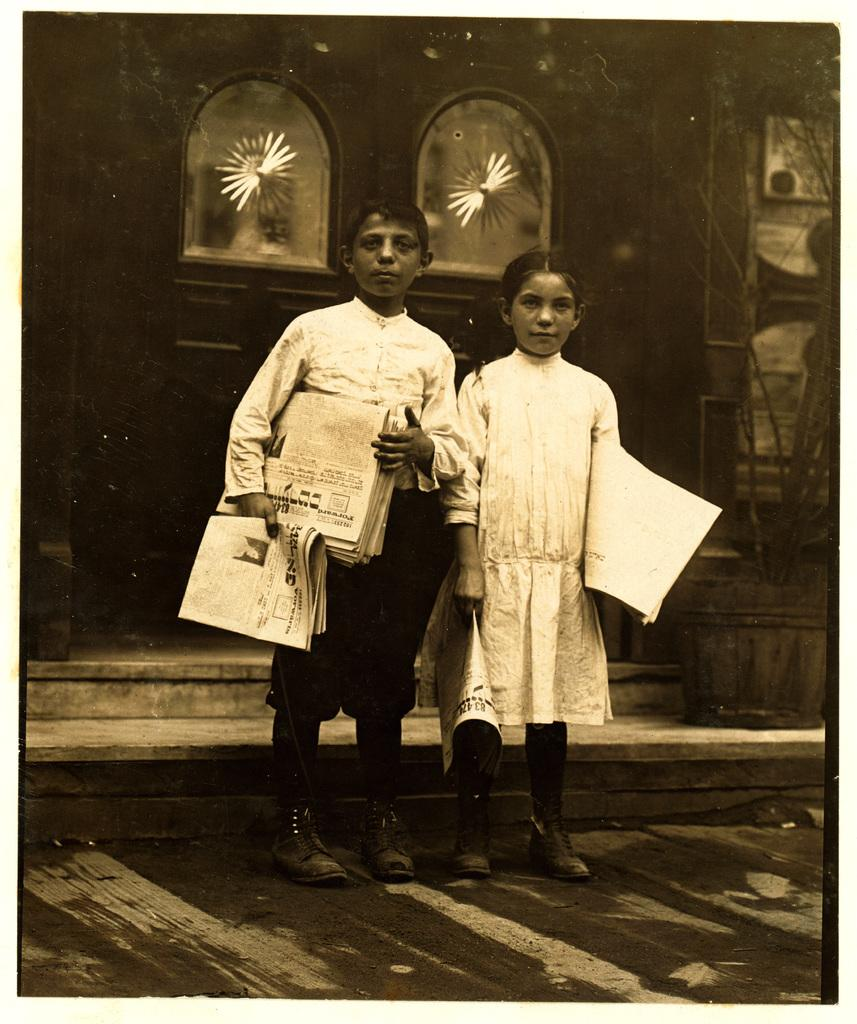How many children are present in the image? There are two children in the image. What are the children holding in their hands? The children are holding papers in their hands. Where are the children located in the image? The children are on the road. What can be seen in the background of the image? There is a building with a door and a plant in a flower pot in the background. What type of canvas is the children using to paint in the image? There is no canvas or painting activity present in the image. What is the children's desire in the image? The image does not provide information about the children's desires or emotions. 